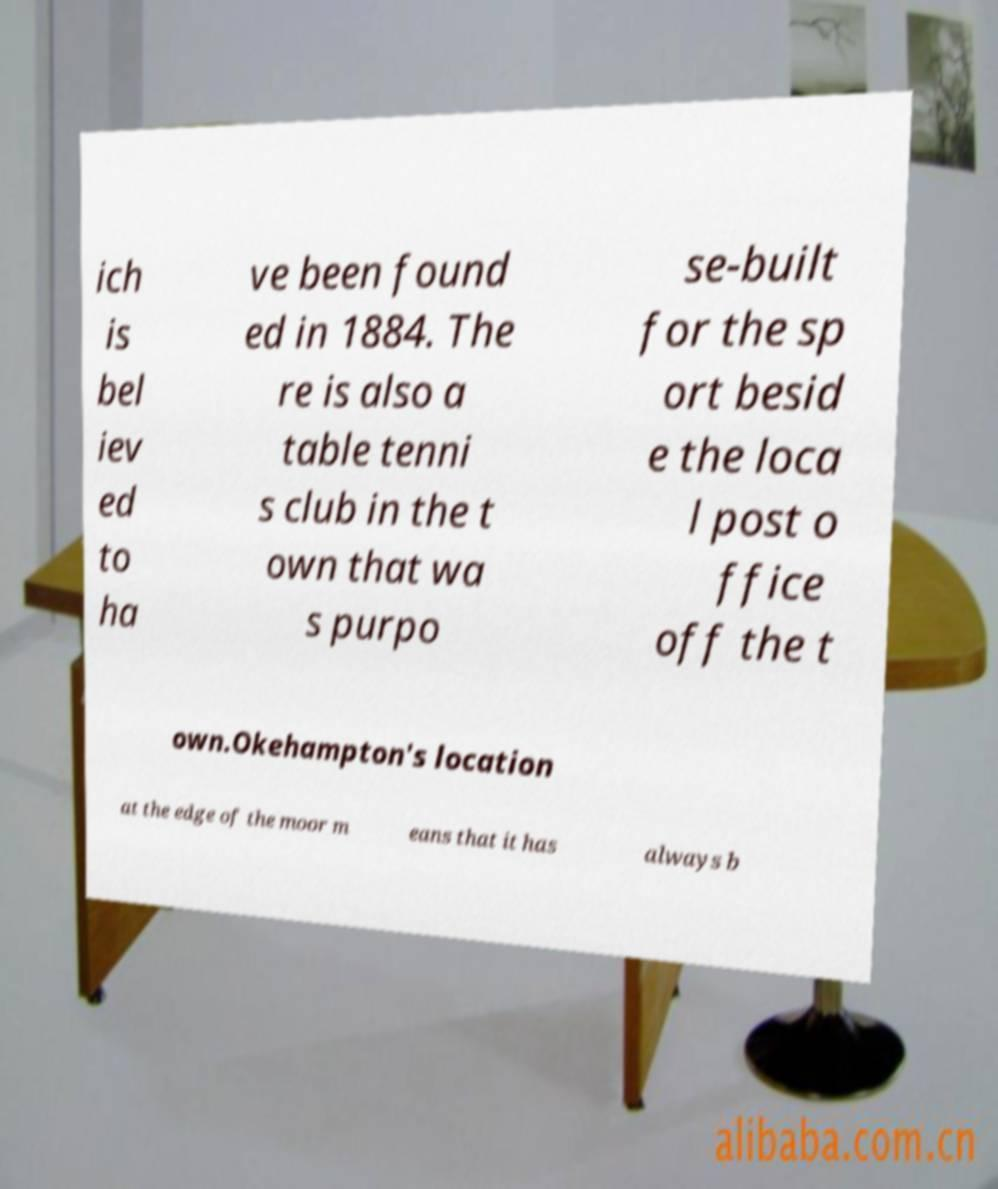I need the written content from this picture converted into text. Can you do that? ich is bel iev ed to ha ve been found ed in 1884. The re is also a table tenni s club in the t own that wa s purpo se-built for the sp ort besid e the loca l post o ffice off the t own.Okehampton's location at the edge of the moor m eans that it has always b 